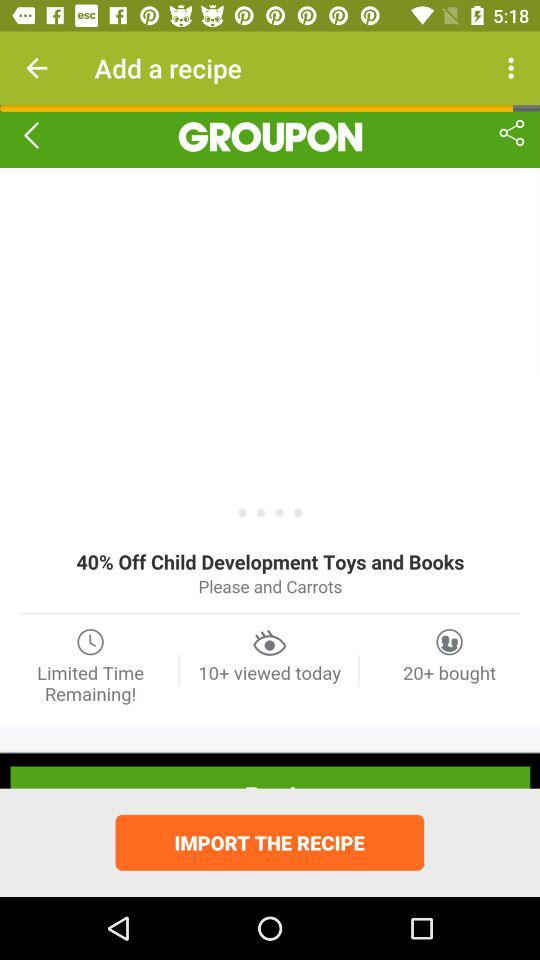How many more times has the recipe been bought than viewed?
Answer the question using a single word or phrase. 10 